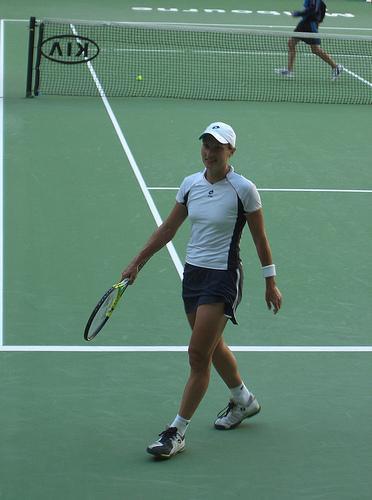How many people are visible?
Give a very brief answer. 2. 